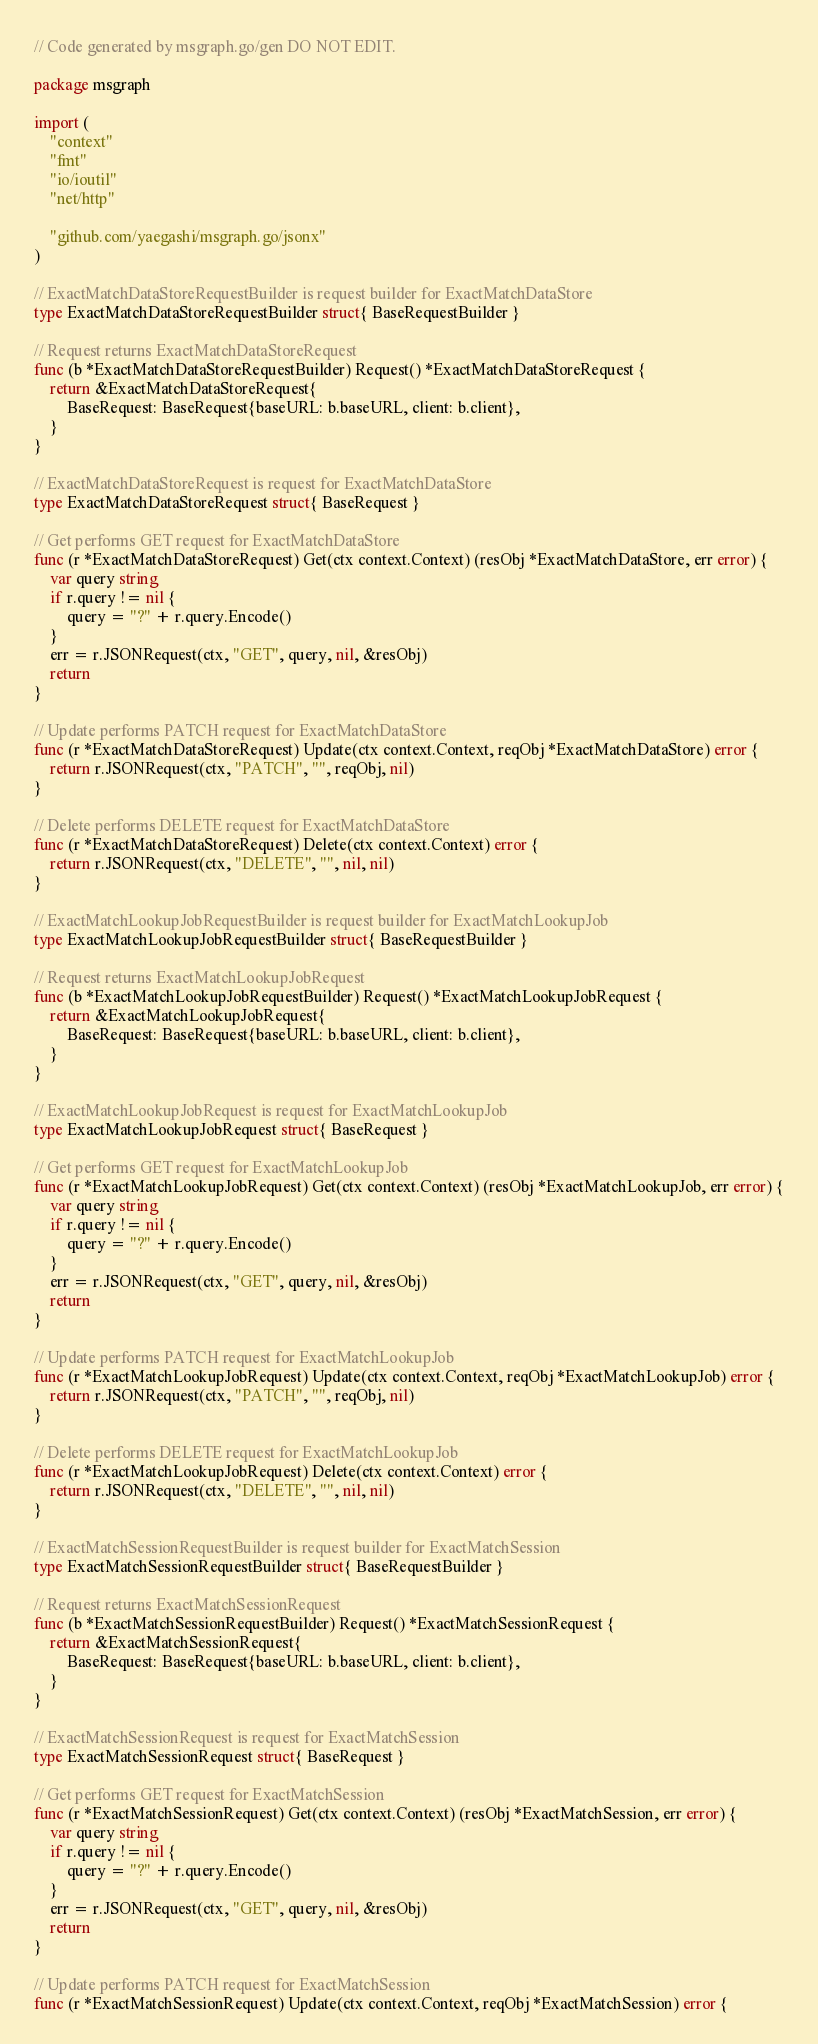Convert code to text. <code><loc_0><loc_0><loc_500><loc_500><_Go_>// Code generated by msgraph.go/gen DO NOT EDIT.

package msgraph

import (
	"context"
	"fmt"
	"io/ioutil"
	"net/http"

	"github.com/yaegashi/msgraph.go/jsonx"
)

// ExactMatchDataStoreRequestBuilder is request builder for ExactMatchDataStore
type ExactMatchDataStoreRequestBuilder struct{ BaseRequestBuilder }

// Request returns ExactMatchDataStoreRequest
func (b *ExactMatchDataStoreRequestBuilder) Request() *ExactMatchDataStoreRequest {
	return &ExactMatchDataStoreRequest{
		BaseRequest: BaseRequest{baseURL: b.baseURL, client: b.client},
	}
}

// ExactMatchDataStoreRequest is request for ExactMatchDataStore
type ExactMatchDataStoreRequest struct{ BaseRequest }

// Get performs GET request for ExactMatchDataStore
func (r *ExactMatchDataStoreRequest) Get(ctx context.Context) (resObj *ExactMatchDataStore, err error) {
	var query string
	if r.query != nil {
		query = "?" + r.query.Encode()
	}
	err = r.JSONRequest(ctx, "GET", query, nil, &resObj)
	return
}

// Update performs PATCH request for ExactMatchDataStore
func (r *ExactMatchDataStoreRequest) Update(ctx context.Context, reqObj *ExactMatchDataStore) error {
	return r.JSONRequest(ctx, "PATCH", "", reqObj, nil)
}

// Delete performs DELETE request for ExactMatchDataStore
func (r *ExactMatchDataStoreRequest) Delete(ctx context.Context) error {
	return r.JSONRequest(ctx, "DELETE", "", nil, nil)
}

// ExactMatchLookupJobRequestBuilder is request builder for ExactMatchLookupJob
type ExactMatchLookupJobRequestBuilder struct{ BaseRequestBuilder }

// Request returns ExactMatchLookupJobRequest
func (b *ExactMatchLookupJobRequestBuilder) Request() *ExactMatchLookupJobRequest {
	return &ExactMatchLookupJobRequest{
		BaseRequest: BaseRequest{baseURL: b.baseURL, client: b.client},
	}
}

// ExactMatchLookupJobRequest is request for ExactMatchLookupJob
type ExactMatchLookupJobRequest struct{ BaseRequest }

// Get performs GET request for ExactMatchLookupJob
func (r *ExactMatchLookupJobRequest) Get(ctx context.Context) (resObj *ExactMatchLookupJob, err error) {
	var query string
	if r.query != nil {
		query = "?" + r.query.Encode()
	}
	err = r.JSONRequest(ctx, "GET", query, nil, &resObj)
	return
}

// Update performs PATCH request for ExactMatchLookupJob
func (r *ExactMatchLookupJobRequest) Update(ctx context.Context, reqObj *ExactMatchLookupJob) error {
	return r.JSONRequest(ctx, "PATCH", "", reqObj, nil)
}

// Delete performs DELETE request for ExactMatchLookupJob
func (r *ExactMatchLookupJobRequest) Delete(ctx context.Context) error {
	return r.JSONRequest(ctx, "DELETE", "", nil, nil)
}

// ExactMatchSessionRequestBuilder is request builder for ExactMatchSession
type ExactMatchSessionRequestBuilder struct{ BaseRequestBuilder }

// Request returns ExactMatchSessionRequest
func (b *ExactMatchSessionRequestBuilder) Request() *ExactMatchSessionRequest {
	return &ExactMatchSessionRequest{
		BaseRequest: BaseRequest{baseURL: b.baseURL, client: b.client},
	}
}

// ExactMatchSessionRequest is request for ExactMatchSession
type ExactMatchSessionRequest struct{ BaseRequest }

// Get performs GET request for ExactMatchSession
func (r *ExactMatchSessionRequest) Get(ctx context.Context) (resObj *ExactMatchSession, err error) {
	var query string
	if r.query != nil {
		query = "?" + r.query.Encode()
	}
	err = r.JSONRequest(ctx, "GET", query, nil, &resObj)
	return
}

// Update performs PATCH request for ExactMatchSession
func (r *ExactMatchSessionRequest) Update(ctx context.Context, reqObj *ExactMatchSession) error {</code> 